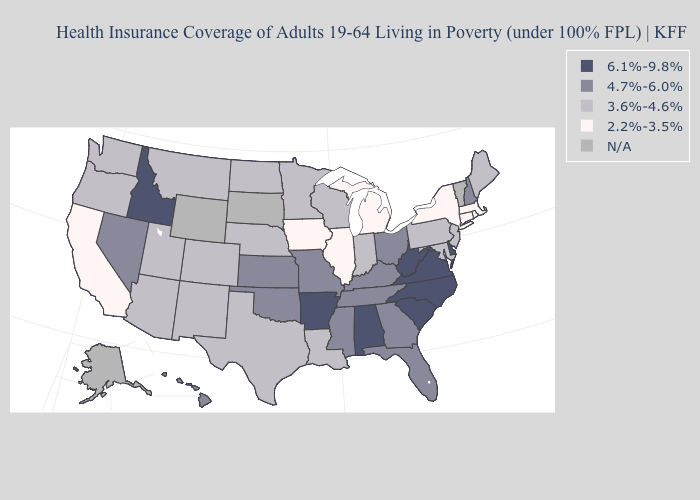Among the states that border Washington , which have the highest value?
Be succinct. Idaho. Name the states that have a value in the range 4.7%-6.0%?
Be succinct. Florida, Georgia, Hawaii, Kansas, Kentucky, Mississippi, Missouri, Nevada, New Hampshire, Ohio, Oklahoma, Tennessee. Name the states that have a value in the range 6.1%-9.8%?
Give a very brief answer. Alabama, Arkansas, Delaware, Idaho, North Carolina, South Carolina, Virginia, West Virginia. What is the value of Hawaii?
Short answer required. 4.7%-6.0%. Which states hav the highest value in the MidWest?
Write a very short answer. Kansas, Missouri, Ohio. Name the states that have a value in the range 4.7%-6.0%?
Quick response, please. Florida, Georgia, Hawaii, Kansas, Kentucky, Mississippi, Missouri, Nevada, New Hampshire, Ohio, Oklahoma, Tennessee. Does Missouri have the highest value in the MidWest?
Short answer required. Yes. What is the value of South Dakota?
Concise answer only. N/A. Which states have the highest value in the USA?
Keep it brief. Alabama, Arkansas, Delaware, Idaho, North Carolina, South Carolina, Virginia, West Virginia. What is the value of California?
Keep it brief. 2.2%-3.5%. Is the legend a continuous bar?
Write a very short answer. No. Name the states that have a value in the range 3.6%-4.6%?
Be succinct. Arizona, Colorado, Indiana, Louisiana, Maine, Maryland, Minnesota, Montana, Nebraska, New Jersey, New Mexico, North Dakota, Oregon, Pennsylvania, Texas, Utah, Washington, Wisconsin. Which states have the lowest value in the MidWest?
Quick response, please. Illinois, Iowa, Michigan. How many symbols are there in the legend?
Answer briefly. 5. Name the states that have a value in the range 3.6%-4.6%?
Answer briefly. Arizona, Colorado, Indiana, Louisiana, Maine, Maryland, Minnesota, Montana, Nebraska, New Jersey, New Mexico, North Dakota, Oregon, Pennsylvania, Texas, Utah, Washington, Wisconsin. 